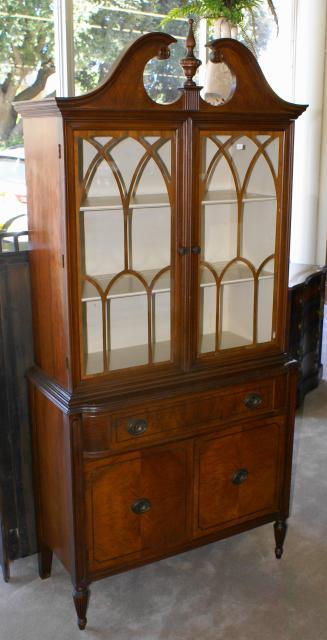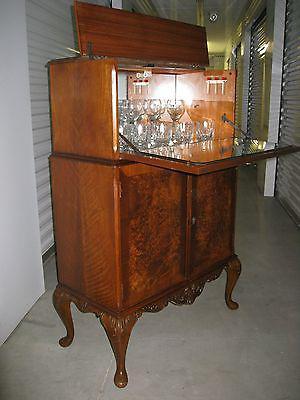The first image is the image on the left, the second image is the image on the right. Assess this claim about the two images: "Both images show just one cabinet with legs, and at least one cabinet has curving legs that end in a rounded foot.". Correct or not? Answer yes or no. Yes. The first image is the image on the left, the second image is the image on the right. For the images displayed, is the sentence "All wooden displays feature clear glass and are completely empty." factually correct? Answer yes or no. No. 